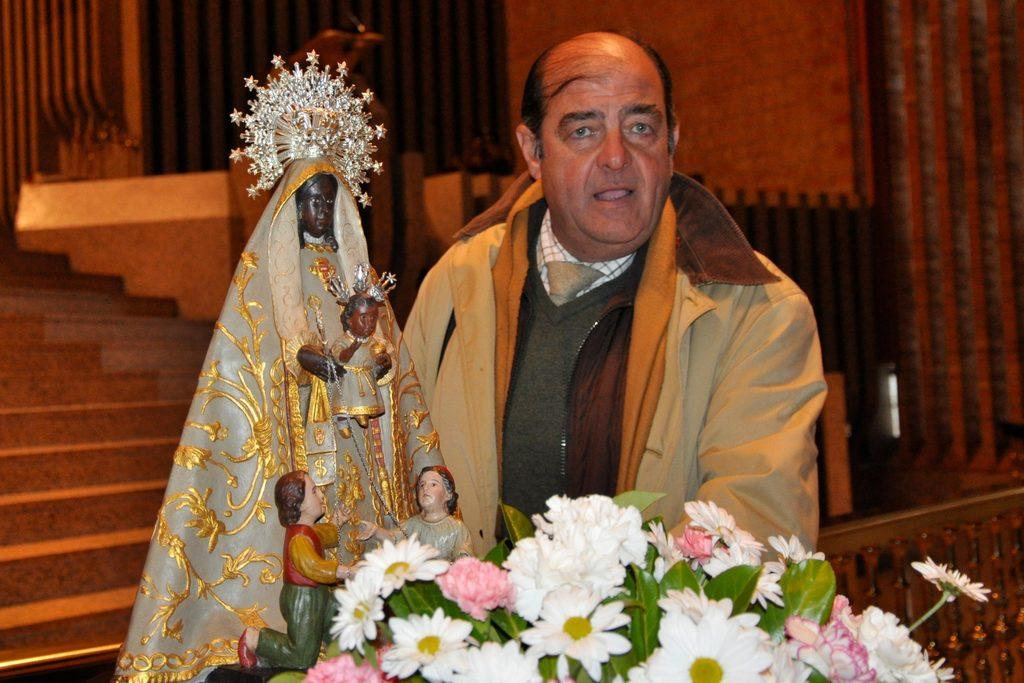What is the main subject in the middle of the image? There is a man standing in the middle of the image. What other objects or features can be seen in the image? There are statues, flowers, stairs, and a wall in the image. Where are the stairs located in the image? The stairs are in the background of the image. What type of vegetation is present at the bottom of the image? There are flowers at the bottom of the image. What type of cherry is being used as a decoration on the man's coat in the image? There is no cherry or coat present in the image; the man is not wearing a coat, and there is no mention of cherries. 